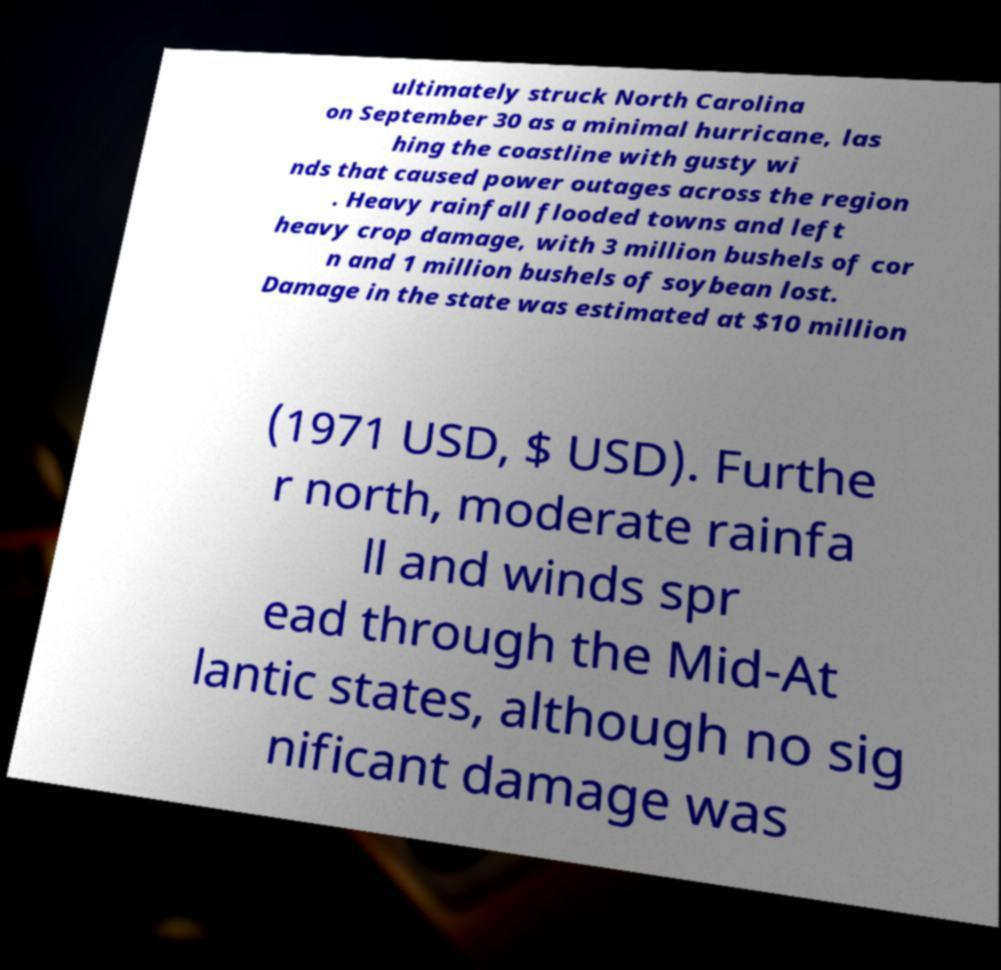What messages or text are displayed in this image? I need them in a readable, typed format. ultimately struck North Carolina on September 30 as a minimal hurricane, las hing the coastline with gusty wi nds that caused power outages across the region . Heavy rainfall flooded towns and left heavy crop damage, with 3 million bushels of cor n and 1 million bushels of soybean lost. Damage in the state was estimated at $10 million (1971 USD, $ USD). Furthe r north, moderate rainfa ll and winds spr ead through the Mid-At lantic states, although no sig nificant damage was 